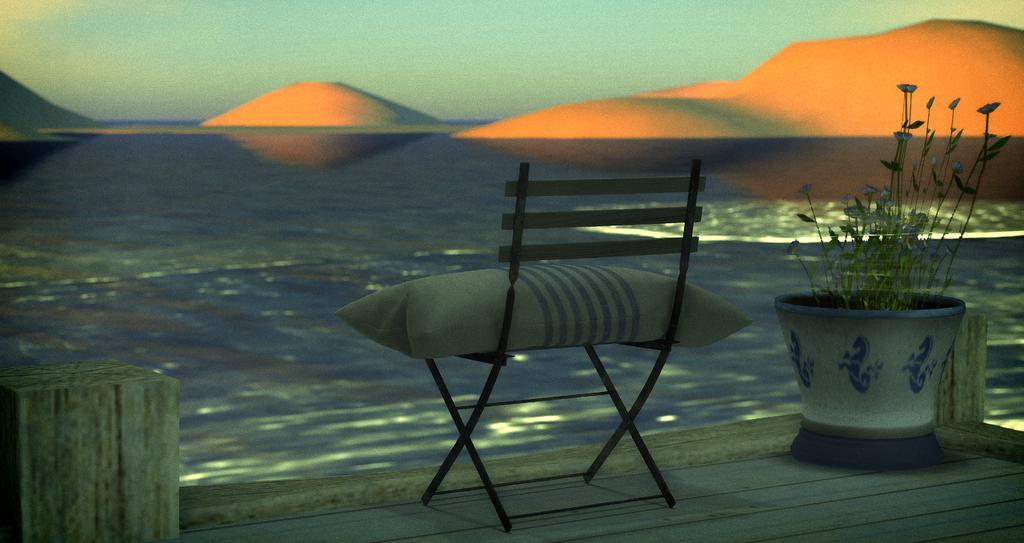In one or two sentences, can you explain what this image depicts? In the picture we can see a wooden path on it we can see a chair and on it we can see a pillow and beside it we can see a plant and behind it we can see water and far away from it we can see some sand hills and sky. 